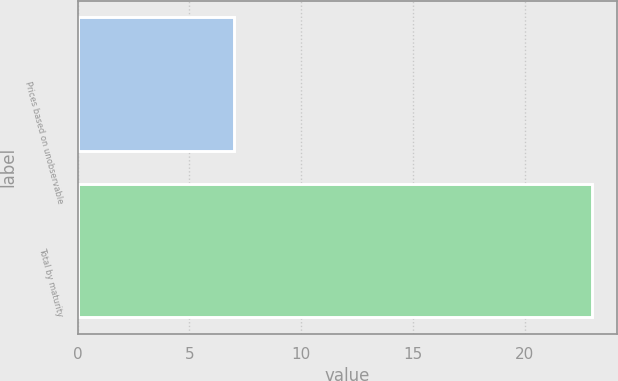<chart> <loc_0><loc_0><loc_500><loc_500><bar_chart><fcel>Prices based on unobservable<fcel>Total by maturity<nl><fcel>7<fcel>23<nl></chart> 